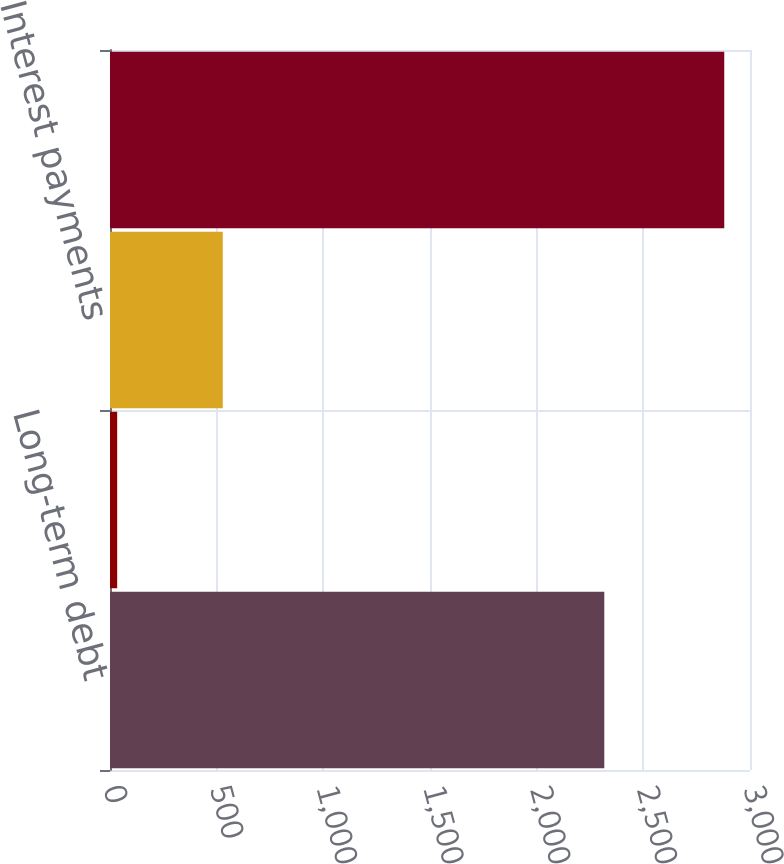Convert chart. <chart><loc_0><loc_0><loc_500><loc_500><bar_chart><fcel>Long-term debt<fcel>Operating leases<fcel>Interest payments<fcel>Total contractual cash<nl><fcel>2317<fcel>33.7<fcel>528.6<fcel>2879.3<nl></chart> 